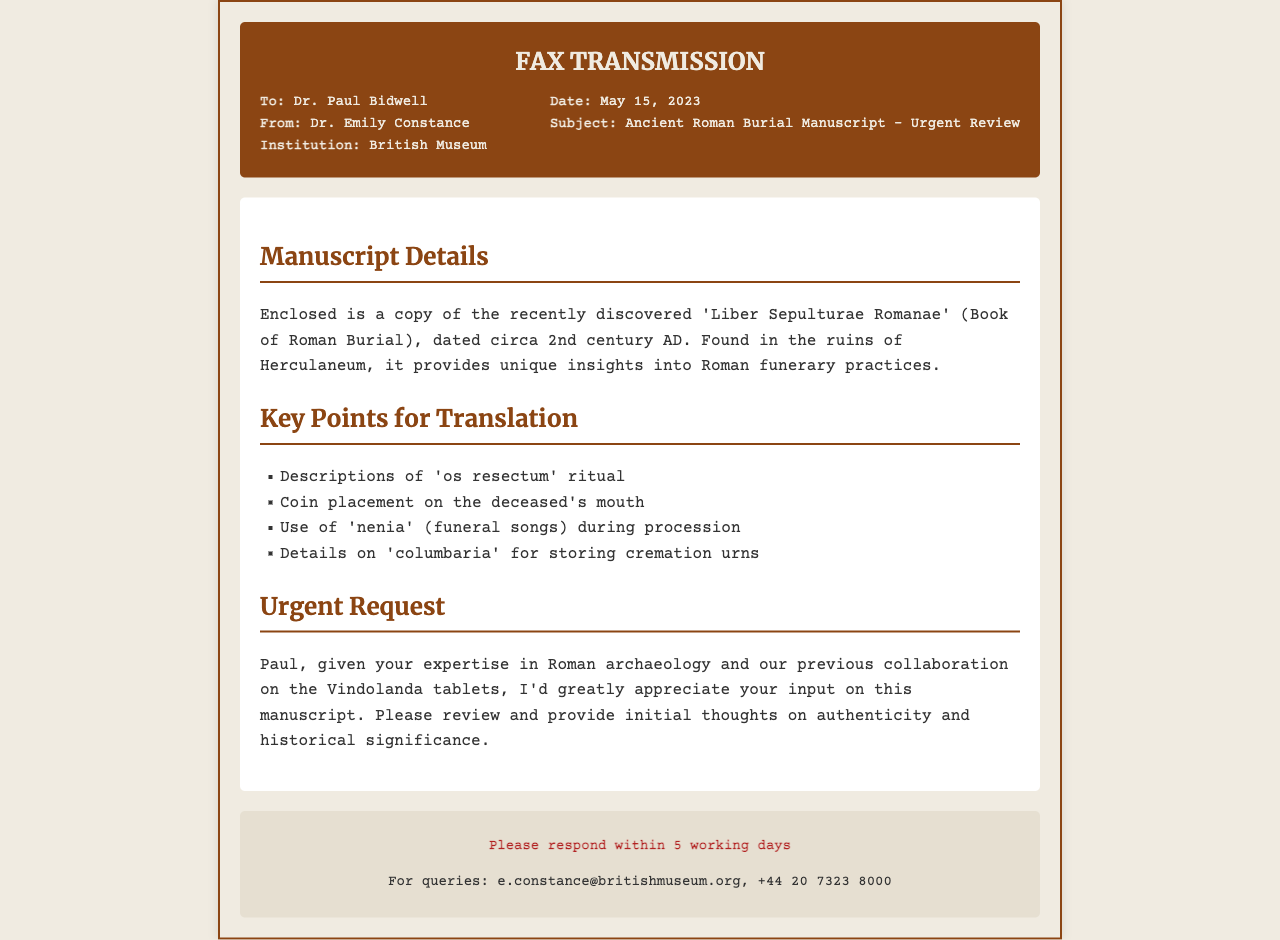What is the title of the manuscript? The title of the manuscript is mentioned in the document as 'Liber Sepulturae Romanae'.
Answer: Liber Sepulturae Romanae Who sent the fax? The sender of the fax is listed in the document as Dr. Emily Constance.
Answer: Dr. Emily Constance What is the date of the fax? The date of the fax is specified in the header as May 15, 2023.
Answer: May 15, 2023 What is the main subject of the fax? The subject of the fax is declared as 'Ancient Roman Burial Manuscript - Urgent Review'.
Answer: Ancient Roman Burial Manuscript - Urgent Review What is the ritual described in the manuscript related to? The manuscript discusses the 'os resectum' ritual, which is one of the key points listed for translation.
Answer: os resectum What location was the manuscript discovered? The manuscript was found in the ruins of Herculaneum.
Answer: Herculaneum What does Dr. Constance request Dr. Bidwell to provide? Dr. Constance requests Dr. Bidwell to review and provide initial thoughts on authenticity and historical significance.
Answer: Review and provide initial thoughts How many working days does Dr. Constance request for a response? The document states that a response is requested within 5 working days.
Answer: 5 working days What is the purpose of the coin placement mentioned? The placement of a coin on the deceased's mouth is one of the unique insights into Roman funerary practices that the manuscript details.
Answer: Coin placement on the deceased's mouth 